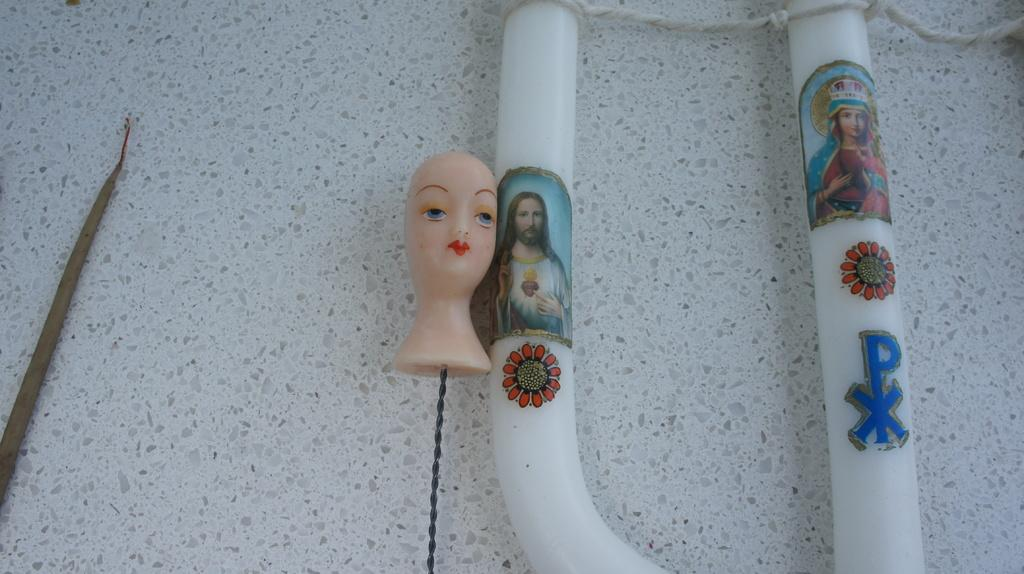What is the main subject of the image? There is an object of a girl in the image. What other objects can be seen in the image? There is another object with Jesus Christ and flower stickers attached to it. Can you describe the background of the image? There is a marble at the back side of the image. What type of relation does the girl have with the bee in the image? There is no bee present in the image, so it is not possible to determine any relation between the girl and a bee. 